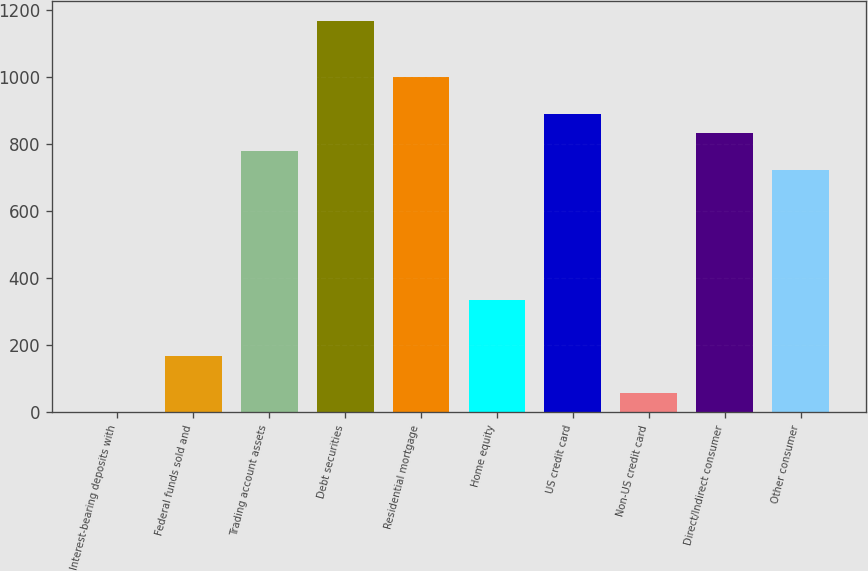Convert chart to OTSL. <chart><loc_0><loc_0><loc_500><loc_500><bar_chart><fcel>Interest-bearing deposits with<fcel>Federal funds sold and<fcel>Trading account assets<fcel>Debt securities<fcel>Residential mortgage<fcel>Home equity<fcel>US credit card<fcel>Non-US credit card<fcel>Direct/Indirect consumer<fcel>Other consumer<nl><fcel>1<fcel>167.8<fcel>779.4<fcel>1168.6<fcel>1001.8<fcel>334.6<fcel>890.6<fcel>56.6<fcel>835<fcel>723.8<nl></chart> 